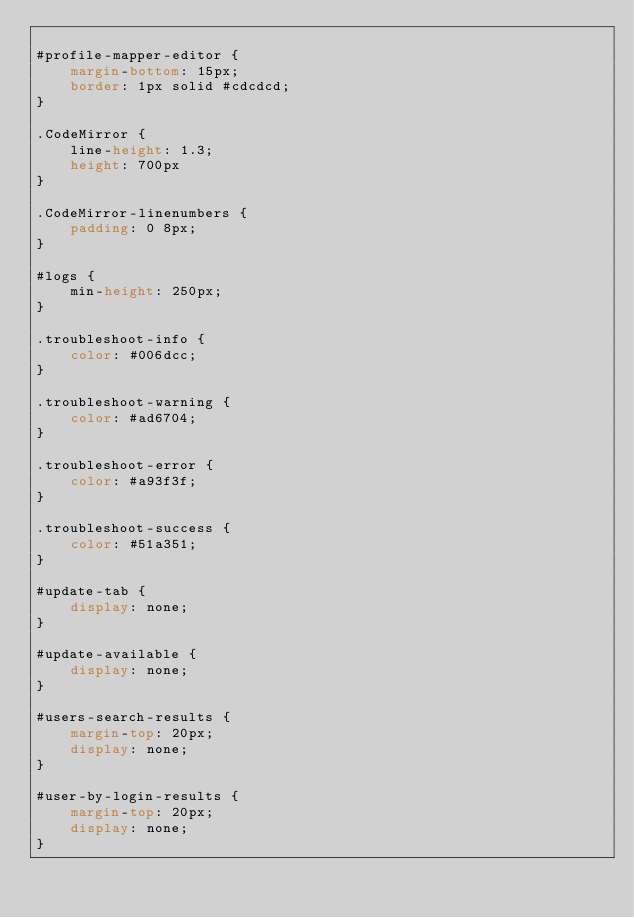Convert code to text. <code><loc_0><loc_0><loc_500><loc_500><_CSS_>
#profile-mapper-editor {
	margin-bottom: 15px;
	border: 1px solid #cdcdcd;
}

.CodeMirror {
	line-height: 1.3;
	height: 700px
}

.CodeMirror-linenumbers {
	padding: 0 8px;
}

#logs {
	min-height: 250px;
}

.troubleshoot-info {
	color: #006dcc;
}

.troubleshoot-warning {
	color: #ad6704;
}

.troubleshoot-error {
	color: #a93f3f;
}

.troubleshoot-success {
	color: #51a351;
}

#update-tab {
	display: none;
}

#update-available {
	display: none;
}

#users-search-results {
	margin-top: 20px;
	display: none;
}

#user-by-login-results {
	margin-top: 20px;
	display: none;
}
</code> 